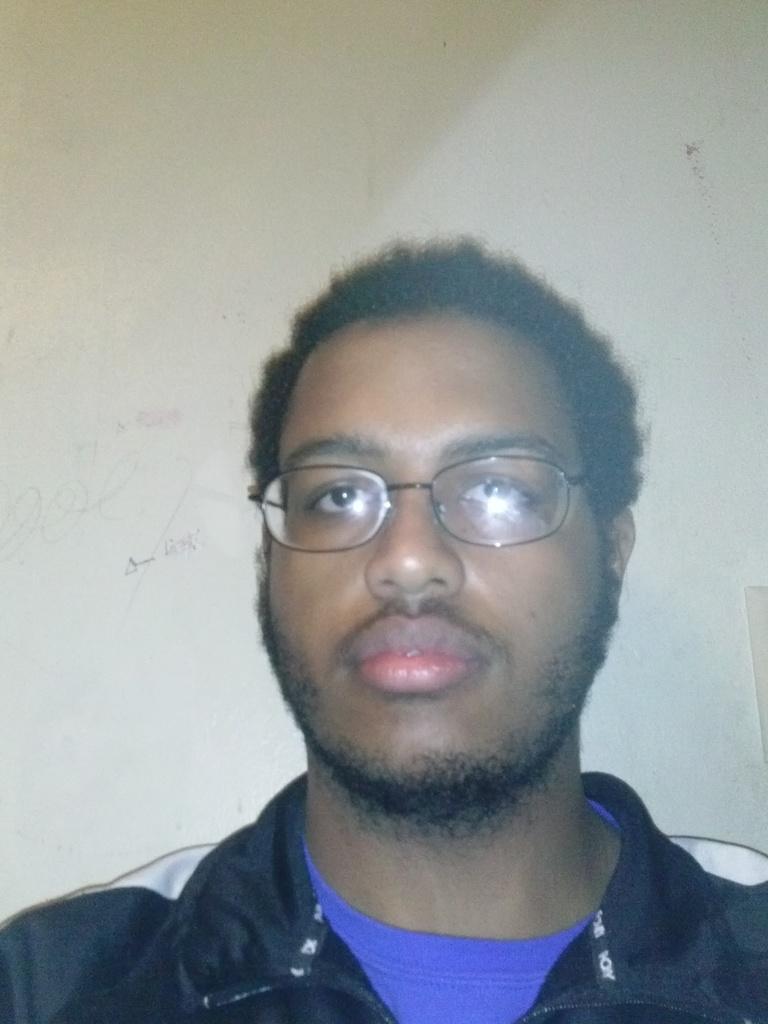Could you give a brief overview of what you see in this image? In this image I can see a person and wall. This image is taken may be in a room. 